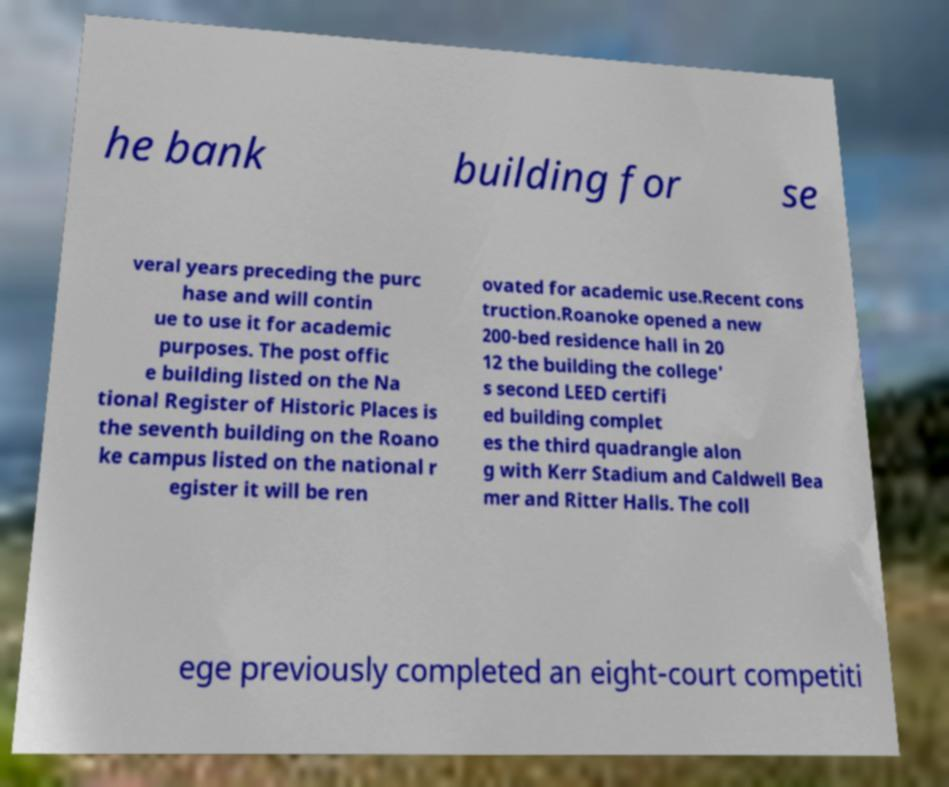Could you assist in decoding the text presented in this image and type it out clearly? he bank building for se veral years preceding the purc hase and will contin ue to use it for academic purposes. The post offic e building listed on the Na tional Register of Historic Places is the seventh building on the Roano ke campus listed on the national r egister it will be ren ovated for academic use.Recent cons truction.Roanoke opened a new 200-bed residence hall in 20 12 the building the college' s second LEED certifi ed building complet es the third quadrangle alon g with Kerr Stadium and Caldwell Bea mer and Ritter Halls. The coll ege previously completed an eight-court competiti 